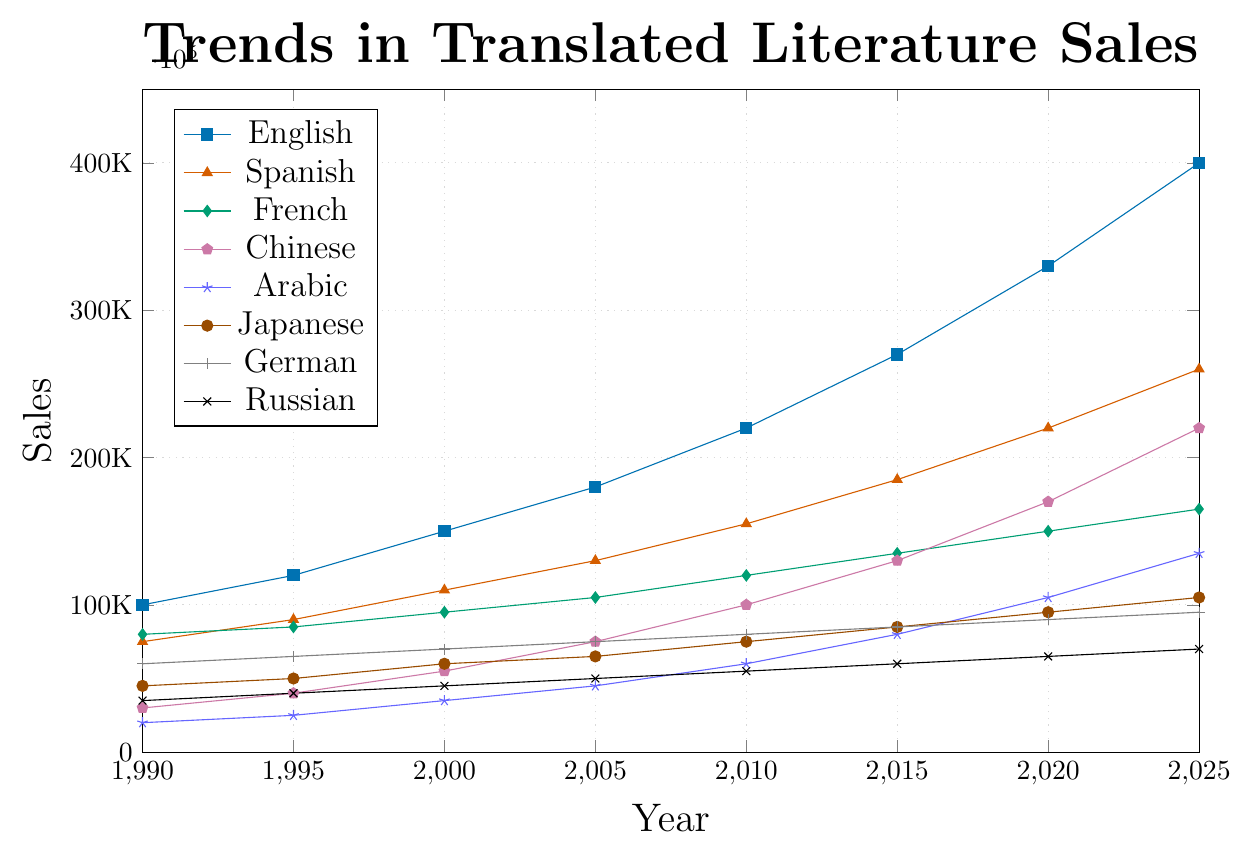What language showed the greatest increase in sales from 1990 to 2025? To find which language had the greatest increase, calculate the difference in sales from the year 2025 and 1990 for each language: English (400000 - 100000 = 300000), Spanish (260000 - 75000 = 185000), French (165000 - 80000 = 85000), Chinese (220000 - 30000 = 190000), Arabic (135000 - 20000 = 115000), Japanese (105000 - 45000 = 60000), German (95000 - 60000 = 35000), Russian (70000 - 35000 = 35000). The greatest increase is for English.
Answer: English Between 2005 and 2020, which language had the smallest growth in sales? To determine the smallest growth, calculate the difference between sales in 2020 and 2005 for each language: English (330000 - 180000 = 150000), Spanish (220000 - 130000 = 90000), French (150000 - 105000 = 45000), Chinese (170000 - 75000 = 95000), Arabic (105000 - 45000 = 60000), Japanese (95000 - 65000 = 30000), German (90000 - 75000 = 15000), Russian (65000 - 50000 = 15000). Both German and Russian had the smallest growth of 15000.
Answer: German and Russian How many times higher were the sales of translated literature in Chinese in 2020 compared to 1990? To find out how many times higher the sales were, divide the 2020 sales by the 1990 sales for Chinese: 170000 / 30000 = 5.67.
Answer: 5.67 What is the average sales of translated literature in Japanese over the period from 1990 to 2025? Add up all the sales figures for Japanese and divide by the number of data points: (45000 + 50000 + 60000 + 65000 + 75000 + 85000 + 95000 + 105000) / 8 = 70000.
Answer: 70000 Which language shows a consistent increasing trend in sales without any dips over the years? By visual inspection of the trend lines, English shows a consistent increasing trend without any dips from 1990 to 2025.
Answer: English In which year did French sales surpass 100,000 for the first time? From the chart, French sales surpassed 100,000 in 2005 where it was listed as 105000.
Answer: 2005 What is the numerical difference between the highest and lowest sales figures in 2025? The highest sales in 2025 is for English (400000) and the lowest is for Russian (70000). The difference is calculated as 400000 - 70000 = 330000.
Answer: 330000 Compare the sales growth trends of Arabic and Japanese from 1990 to 2025. Which language grew faster overall? Calculate the total growth for both languages from 1990 to 2025: Arabic (135000 - 20000 = 115000), Japanese (105000 - 45000 = 60000). Arabic grew faster overall.
Answer: Arabic 